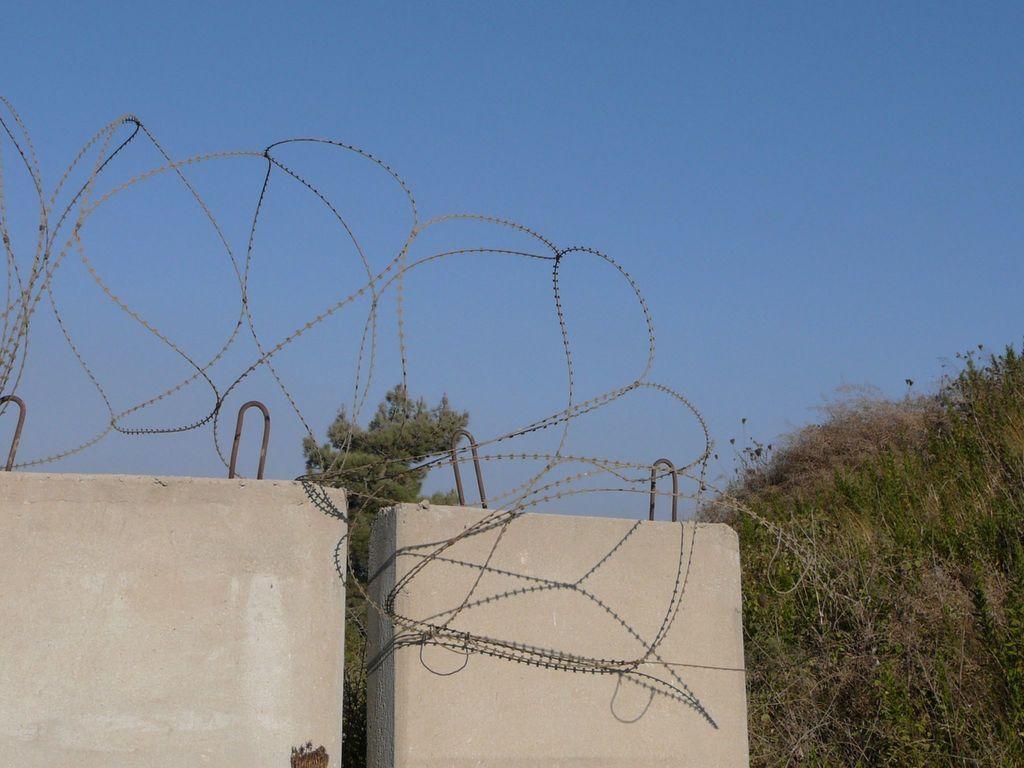Could you give a brief overview of what you see in this image? In this image there are walls, plants, iron wire, and in the background there is sky. 